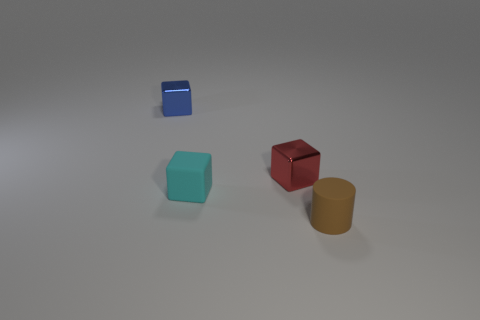There is a red object that is in front of the tiny metal cube to the left of the tiny red thing; what is its material?
Ensure brevity in your answer.  Metal. There is a cyan thing that is the same shape as the tiny blue metallic thing; what is its material?
Offer a terse response. Rubber. Are any large gray matte things visible?
Give a very brief answer. No. There is a tiny brown thing that is the same material as the cyan block; what is its shape?
Your answer should be compact. Cylinder. There is a tiny cube that is behind the tiny red thing; what is its material?
Offer a terse response. Metal. Is the color of the small matte thing on the left side of the tiny brown cylinder the same as the rubber cylinder?
Your answer should be very brief. No. Are there more things behind the tiny cyan matte cube than blue metallic things?
Give a very brief answer. Yes. The object that is in front of the red metallic thing and to the left of the tiny red metal cube is what color?
Your response must be concise. Cyan. There is a brown matte thing that is the same size as the blue thing; what is its shape?
Keep it short and to the point. Cylinder. Is there another rubber block of the same color as the matte cube?
Your answer should be very brief. No. 